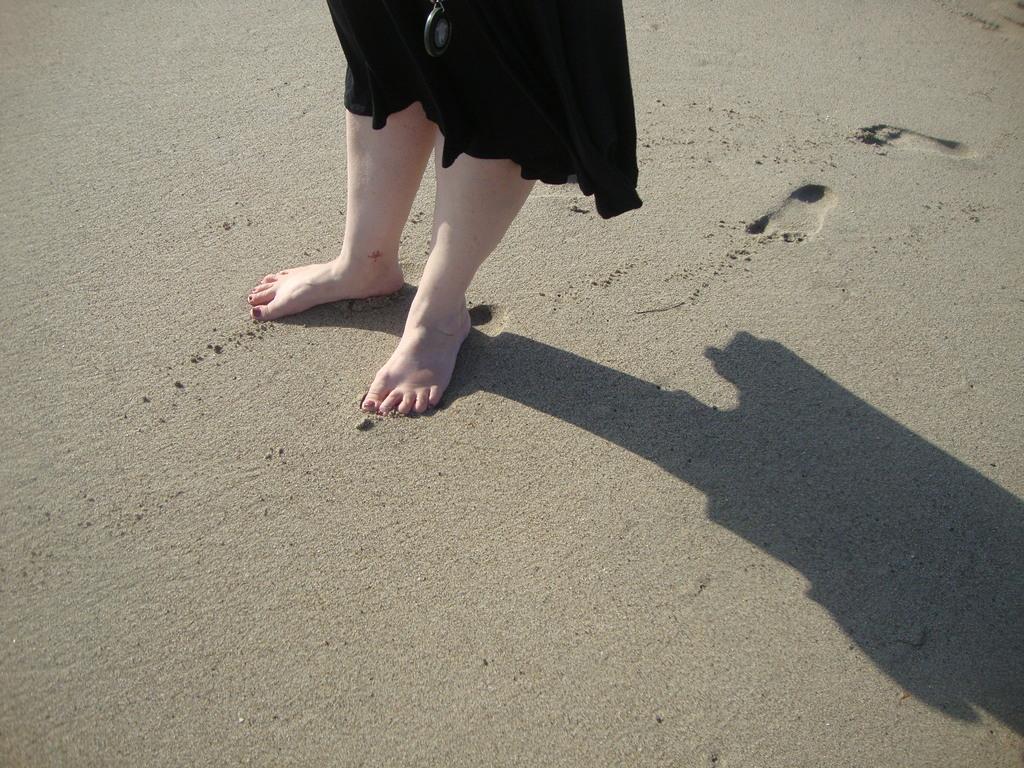How would you summarize this image in a sentence or two? In this image we can see the legs of a person on the sand, also we can see footprints, and the shadow. 